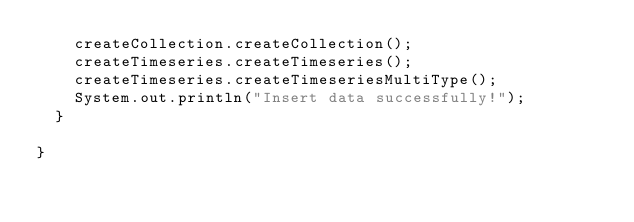<code> <loc_0><loc_0><loc_500><loc_500><_Java_>		createCollection.createCollection();
		createTimeseries.createTimeseries();
		createTimeseries.createTimeseriesMultiType();
		System.out.println("Insert data successfully!");
	}

}
</code> 